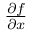Convert formula to latex. <formula><loc_0><loc_0><loc_500><loc_500>\frac { \partial f } { \partial x }</formula> 